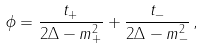<formula> <loc_0><loc_0><loc_500><loc_500>\phi = \frac { t _ { + } } { 2 \Delta - m _ { + } ^ { 2 } } + \frac { t _ { - } } { 2 \Delta - m _ { - } ^ { 2 } } \, ,</formula> 